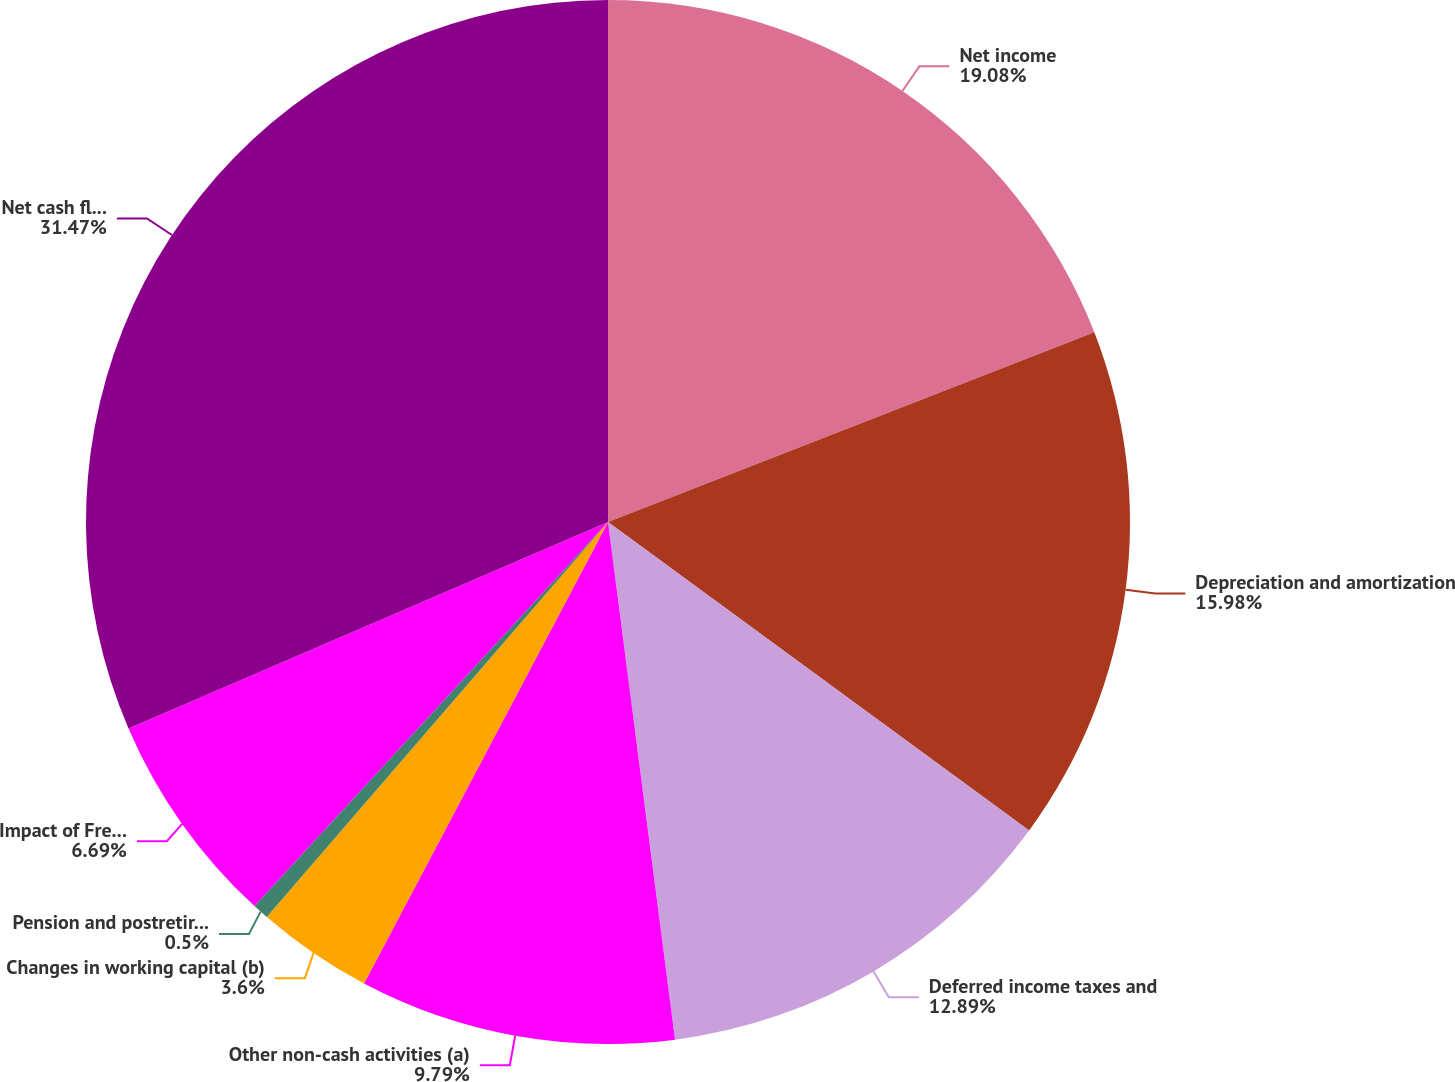Convert chart. <chart><loc_0><loc_0><loc_500><loc_500><pie_chart><fcel>Net income<fcel>Depreciation and amortization<fcel>Deferred income taxes and<fcel>Other non-cash activities (a)<fcel>Changes in working capital (b)<fcel>Pension and postretirement<fcel>Impact of Freedom Industries<fcel>Net cash flows provided by<nl><fcel>19.08%<fcel>15.98%<fcel>12.89%<fcel>9.79%<fcel>3.6%<fcel>0.5%<fcel>6.69%<fcel>31.47%<nl></chart> 